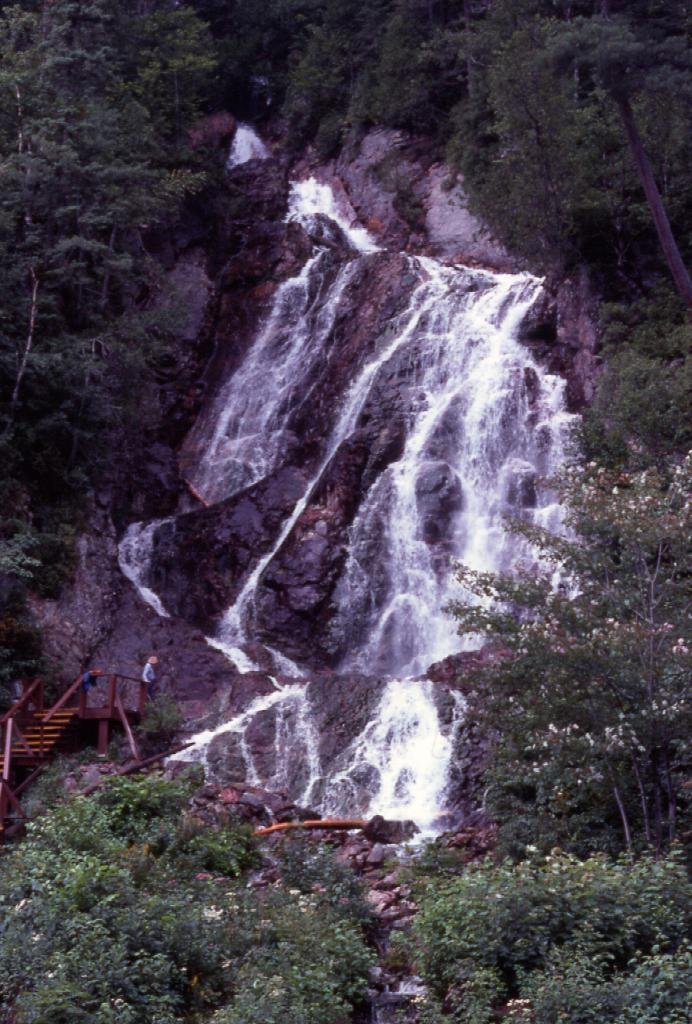What is the main feature in the middle of the image? There is a waterfall in the middle of the image. What type of vegetation surrounds the waterfall? Trees are present on either side of the waterfall. Can you see any structures in the image? Yes, there appears to be a person standing on a bridge on the left side of the image. What type of statement can be seen written on the waterfall in the image? There is no statement written on the waterfall in the image. Can you see any soap bubbles floating near the waterfall in the image? There are no soap bubbles present in the image. 